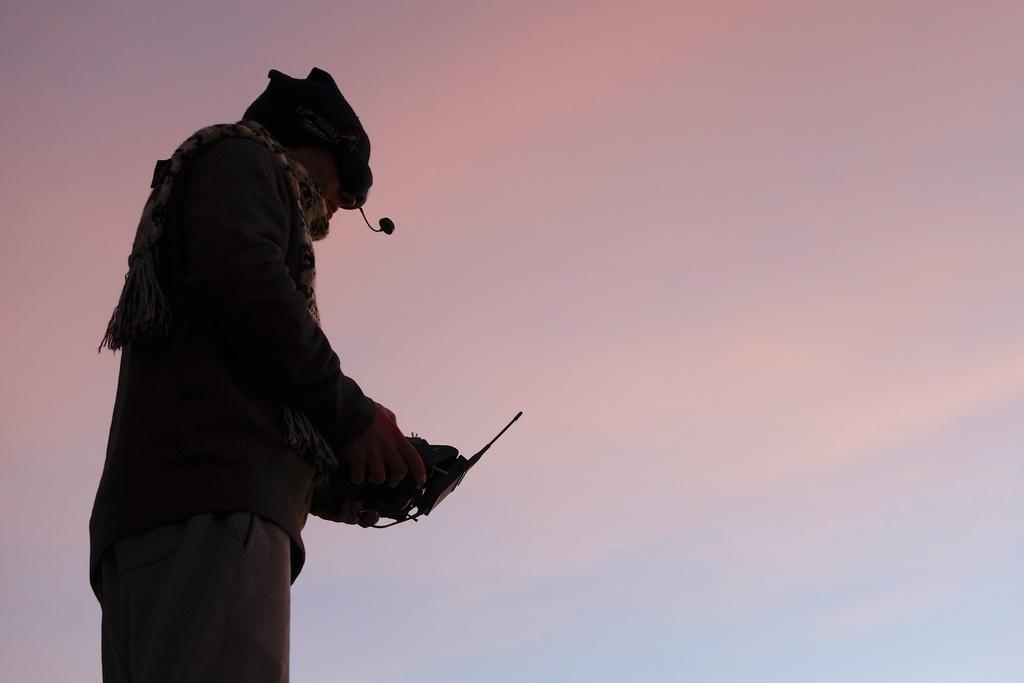What is the main subject of the image? The main subject of the image is a man. What is the man wearing on his head? The man is wearing a cap. What is the man wearing around his neck? The man is wearing a scarf. What object is the man holding in his hand? The man is holding a remote. What can be seen in the background of the image? The sky is visible in the background of the image. What type of skirt is the man wearing in the image? The man is not wearing a skirt in the image; he is wearing a cap and a scarf. How many snails can be seen crawling on the man's shoes in the image? There are no snails visible in the image; the man is wearing a cap, a scarf, and holding a remote. 